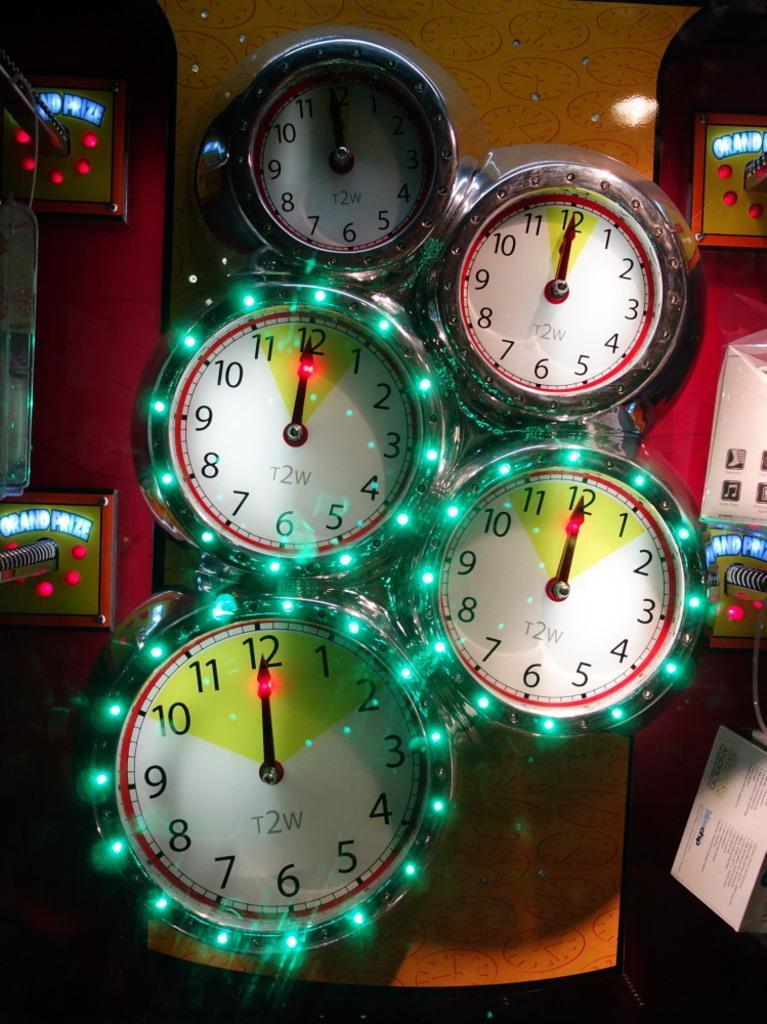Describe this image in one or two sentences. In this image I can see few blocks attached to the orange color surface and I can see few lights in green, red and blue color. 